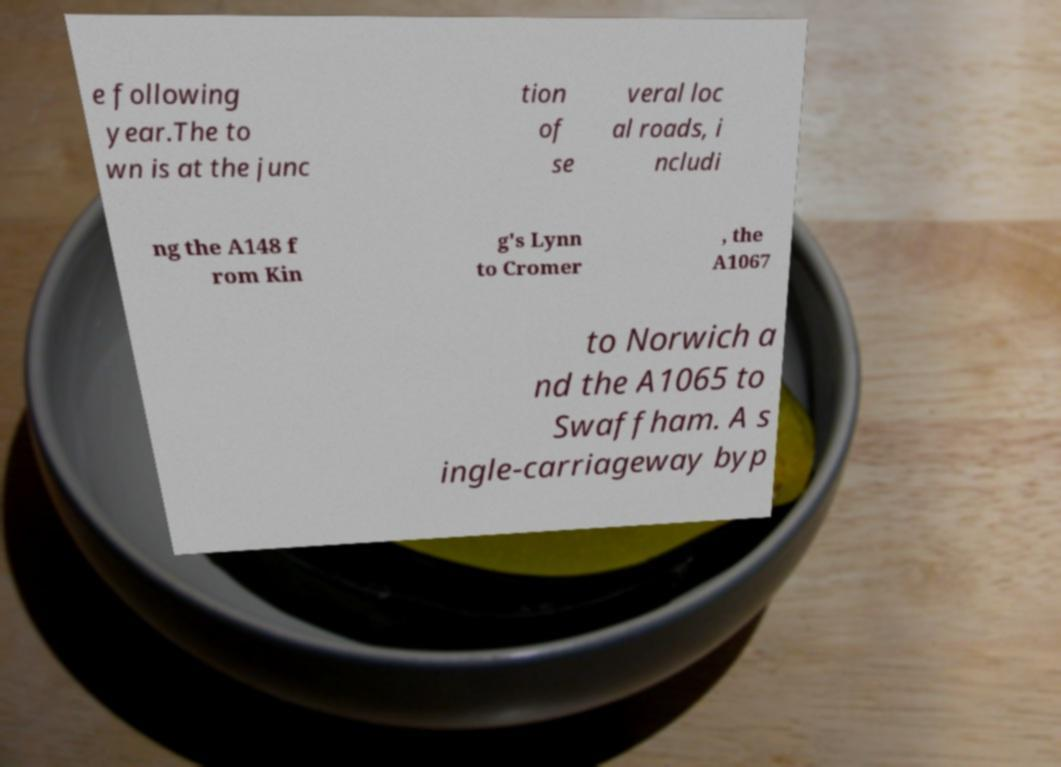What messages or text are displayed in this image? I need them in a readable, typed format. e following year.The to wn is at the junc tion of se veral loc al roads, i ncludi ng the A148 f rom Kin g's Lynn to Cromer , the A1067 to Norwich a nd the A1065 to Swaffham. A s ingle-carriageway byp 